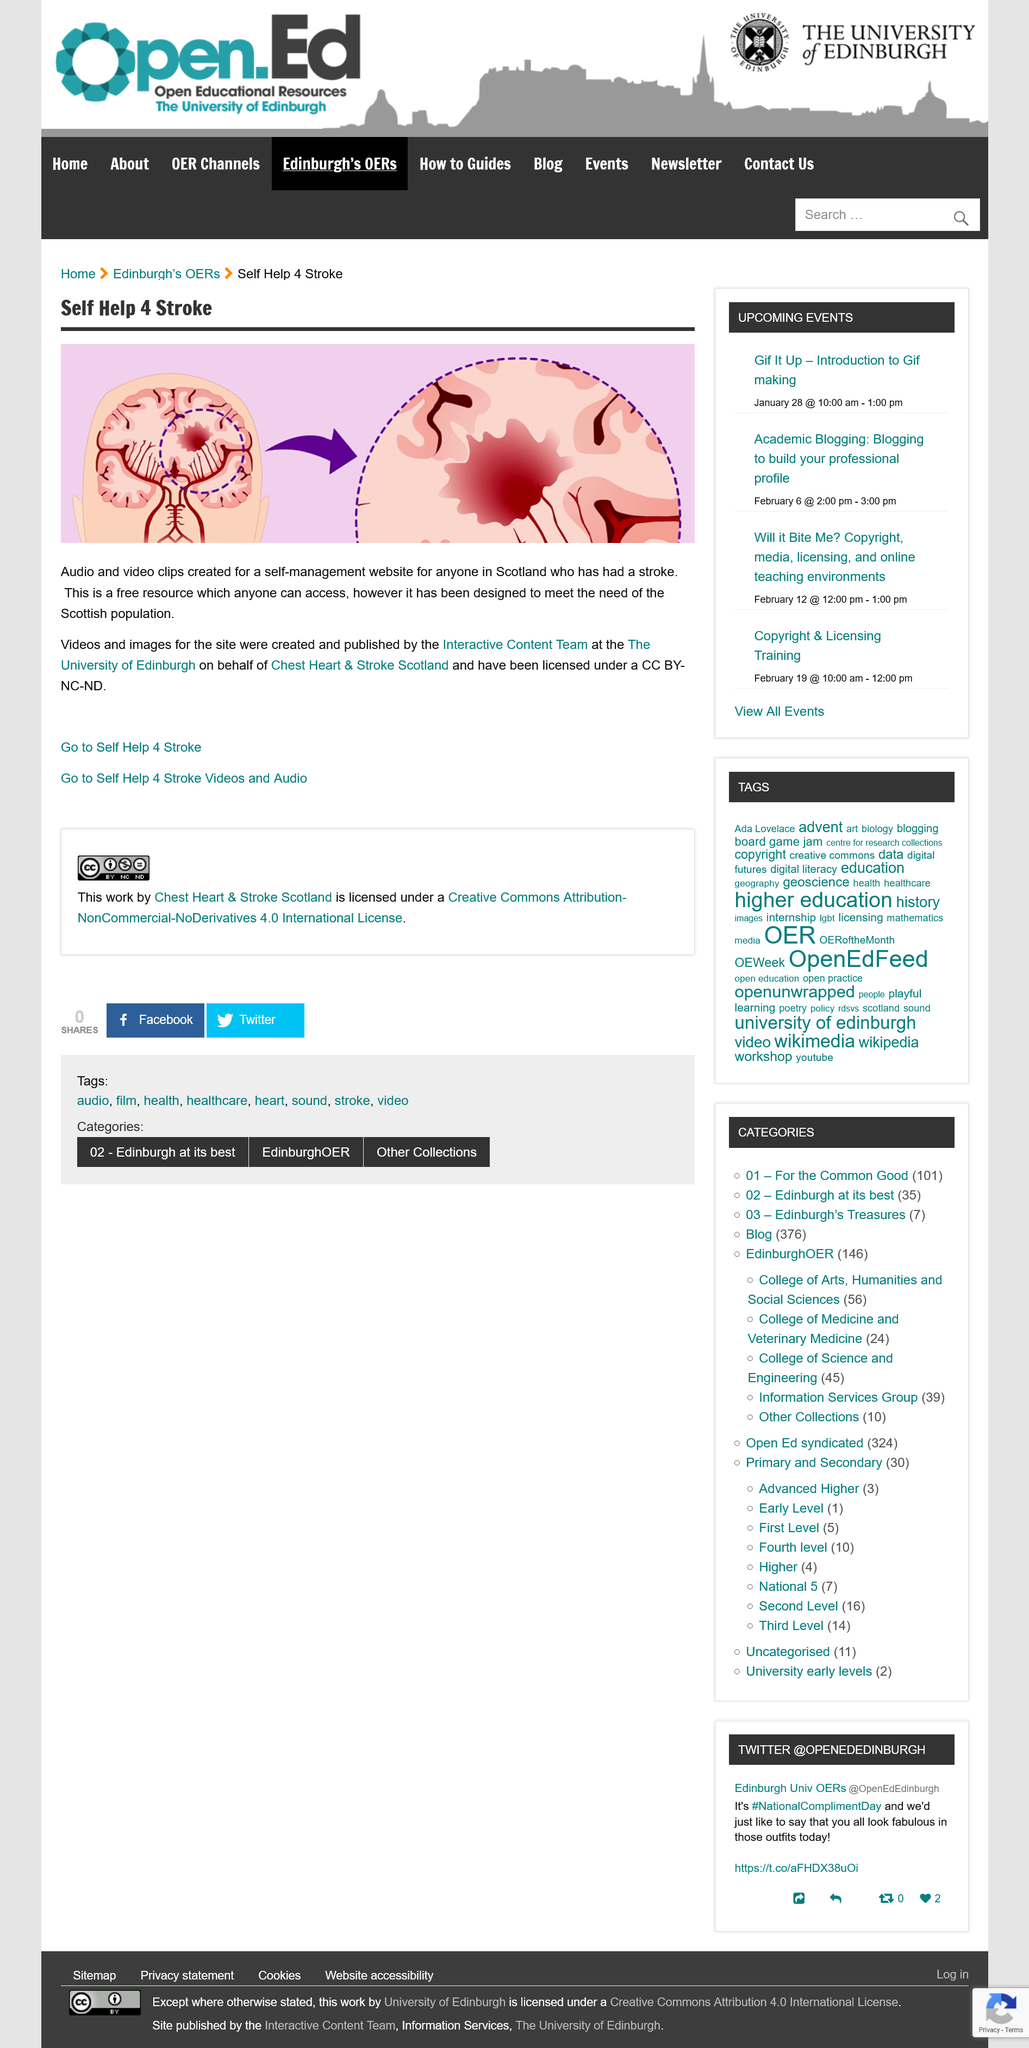Point out several critical features in this image. The Interactive Content Team produced the videos and images for the site on behalf of Chest Heart & Stroke Scotland for the organization. Who is the Self Help 4 Stroke resource designed to help? The Self Help 4 Stroke resource is a free resource that is designed to meet the needs of the Scottish population, and is accessible to anyone. The videos for the Self Help 4 Stroke resource were created by the Interactive Content team at the University of Edinburgh. 